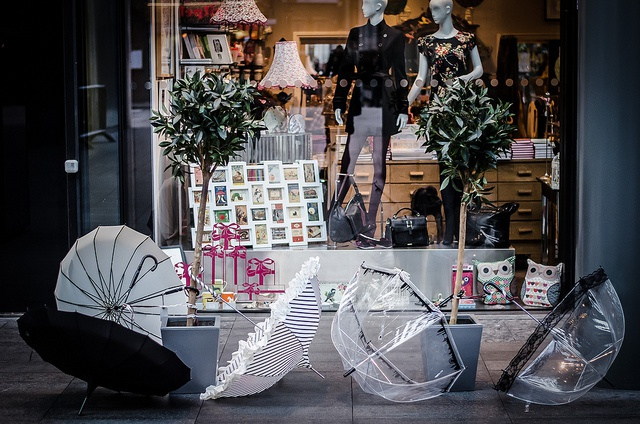Describe the objects in this image and their specific colors. I can see potted plant in black, gray, darkgray, and lightgray tones, potted plant in black, gray, darkgray, and lightgray tones, umbrella in black, darkgray, lightgray, and gray tones, potted plant in black, gray, darkgray, and blue tones, and umbrella in black, gray, and darkblue tones in this image. 